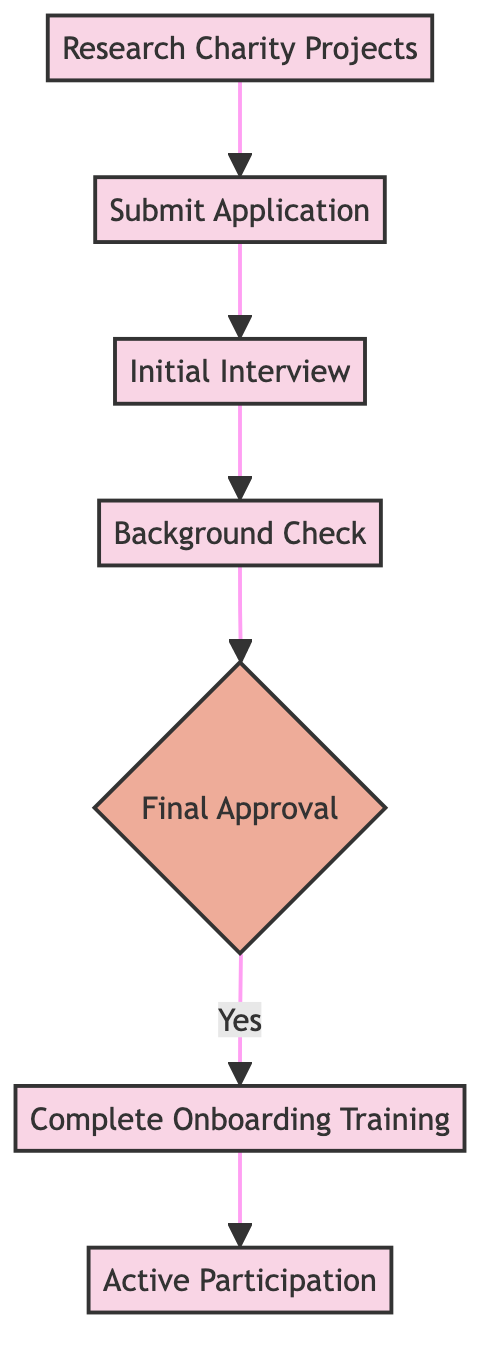What is the first step to become a mentor or volunteer? The first step in the diagram is "Research Charity Projects," indicating that one should begin by exploring the charity's website and current projects.
Answer: Research Charity Projects How many decision points are in the diagram? The diagram contains one decision point, which is labeled "Final Approval," where the flow branches based on the outcome of the approval process.
Answer: 1 What do you do after the initial interview? After completing the "Initial Interview," the next step is "Background Check," indicating that the process moves forward to this stage.
Answer: Background Check What is the last step of the process? The last step in the flowchart is "Active Participation," which signifies that once all prior steps are completed successfully, the individual can engage actively in charity projects.
Answer: Active Participation What is required before completing onboarding training? Before completing "Onboarding Training," the participant must receive "Final Approval," which ensures they have passed the necessary checks and requirements.
Answer: Final Approval How many processes are there in total? There are five process nodes in the flowchart, including "Research Charity Projects," "Submit Application," "Initial Interview," "Background Check," and "Complete Onboarding Training."
Answer: 5 What happens if the final approval is not granted? If "Final Approval" is not granted, the flow does not proceed to "Complete Onboarding Training," implying that the next steps are not possible without approval.
Answer: No onboarding training What is the purpose of the background check? The "Background Check" process is designed to ensure the safety and integrity of the charity's environment, confirming that volunteers or mentors meet safety guidelines.
Answer: Safety and integrity What is the immediate step following the background check? The step that directly follows the "Background Check" is the "Final Approval," where the results of the background check and other criteria are evaluated for final decision-making.
Answer: Final Approval 